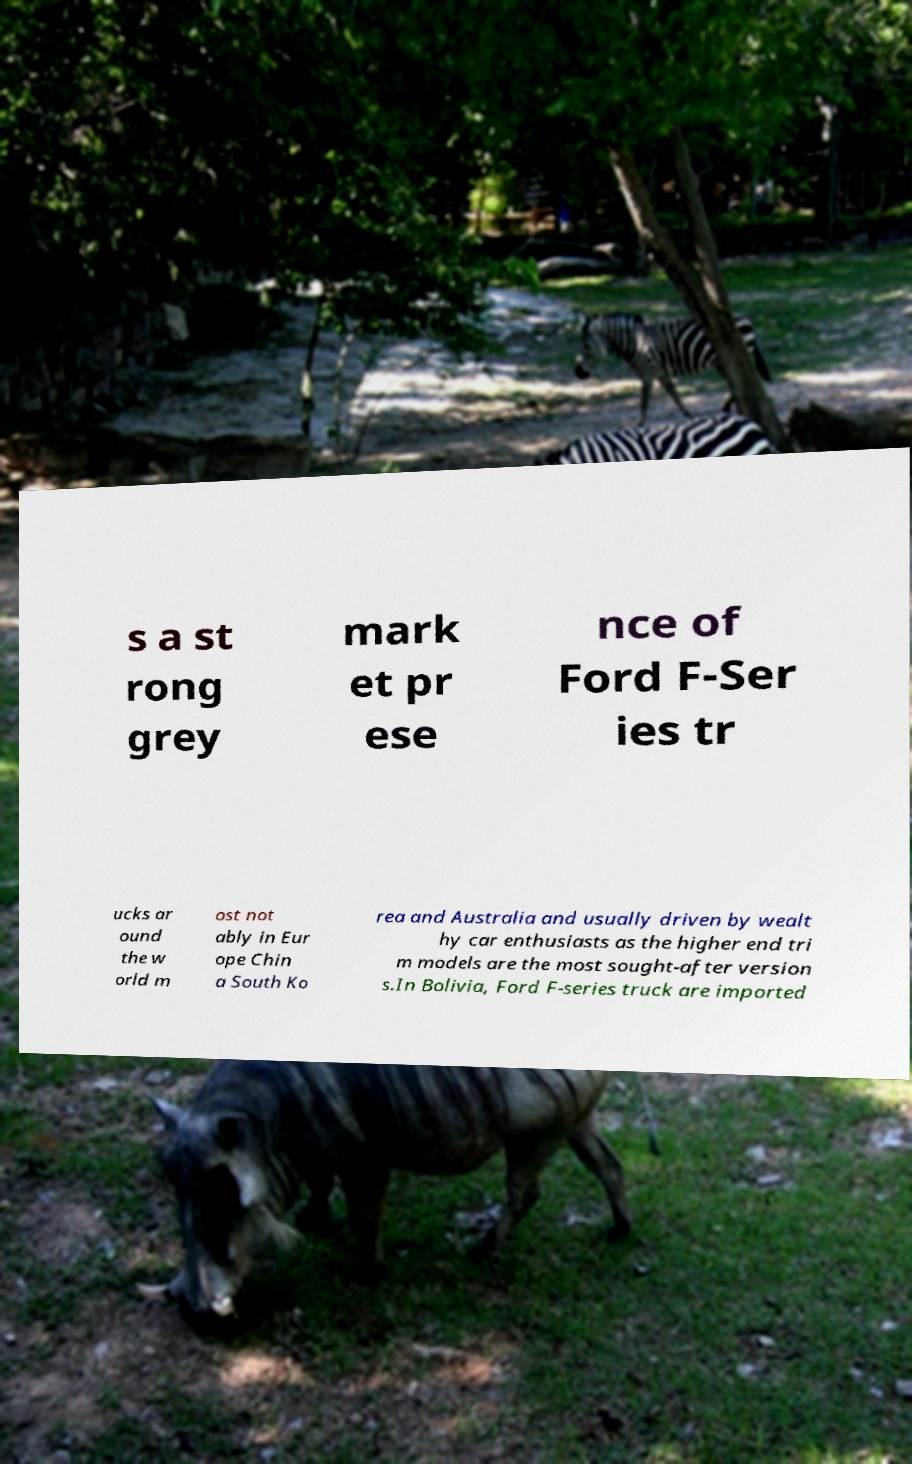For documentation purposes, I need the text within this image transcribed. Could you provide that? s a st rong grey mark et pr ese nce of Ford F-Ser ies tr ucks ar ound the w orld m ost not ably in Eur ope Chin a South Ko rea and Australia and usually driven by wealt hy car enthusiasts as the higher end tri m models are the most sought-after version s.In Bolivia, Ford F-series truck are imported 